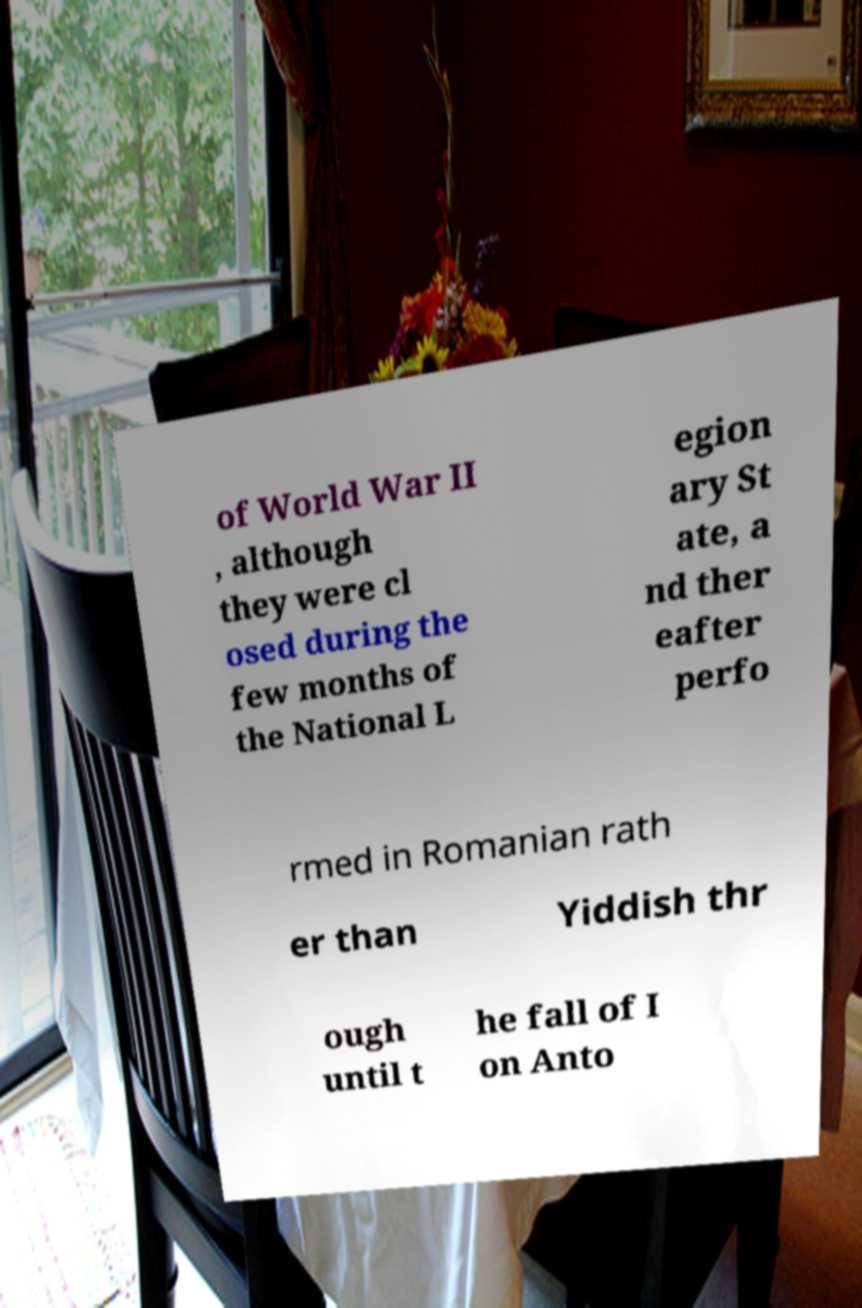For documentation purposes, I need the text within this image transcribed. Could you provide that? of World War II , although they were cl osed during the few months of the National L egion ary St ate, a nd ther eafter perfo rmed in Romanian rath er than Yiddish thr ough until t he fall of I on Anto 